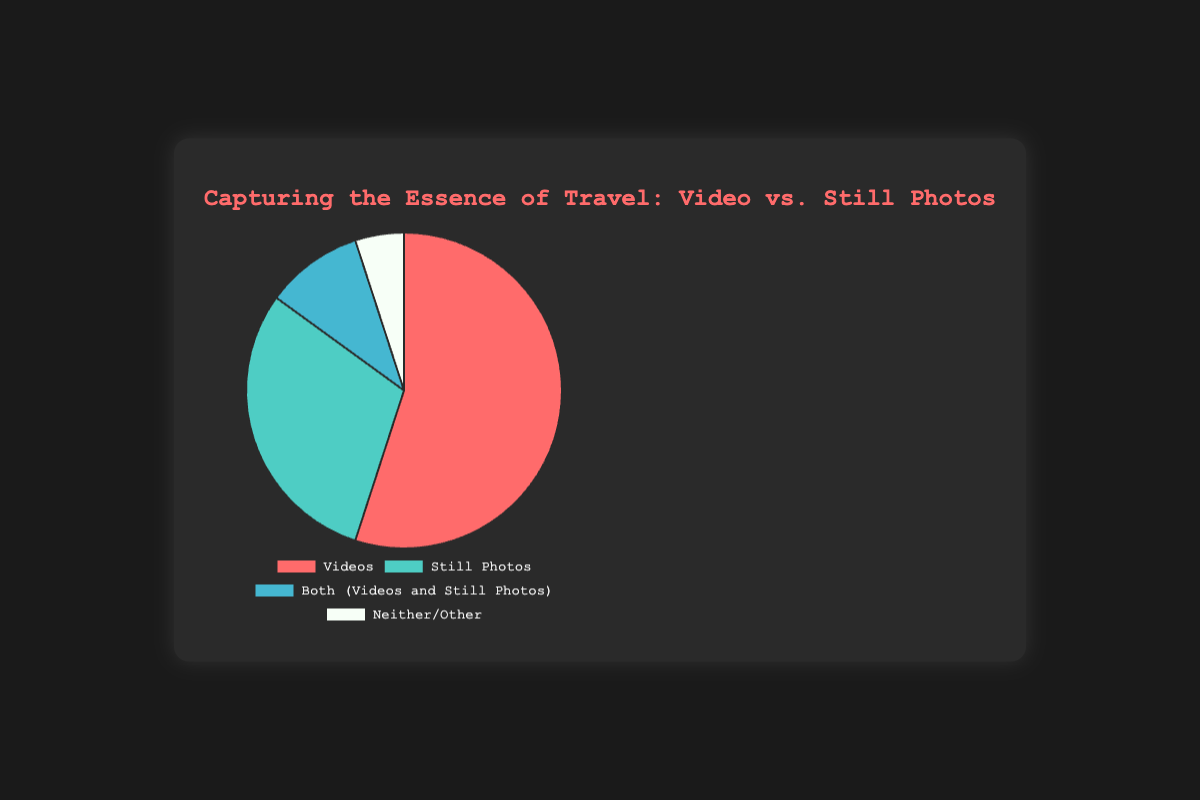What percentage of travelers prefer videos over still photos? The pie chart shows that 55% of travelers prefer videos, while 30% prefer still photos. Therefore, the percentage of travelers that prefer videos over still photos can be directly read from the chart.
Answer: 55% What is the combined percentage of travelers who prefer either videos or both (videos and still photos)? The pie chart displays 55% of travelers preferring videos and 10% preferring both. Adding these percentages gives 55% + 10%.
Answer: 65% Which category has the least preference among travelers? Analyzing the pie chart for the smallest segment reveals that "Neither/Other" has the least preference, accounting for only 5% of travelers.
Answer: Neither/Other, 5% By how much is the preference for videos greater than that for still photos? The chart shows 55% for videos and 30% for still photos. Subtraction will give the difference: 55% - 30%.
Answer: 25% What is the color representing the preference for both videos and still photos? The chart uses colors to differentiate between the categories. The segment for "Both (Videos and Still Photos)" is represented by a light blue color in the pie chart.
Answer: Light blue If 200 travelers were surveyed, how many of them prefer still photos? According to the chart, 30% of travelers prefer still photos. Calculating 30% of 200 (0.30 * 200) gives the number of travelers.
Answer: 60 What percentage of travelers do not prefer videos at all (still photos or neither)? Adding the percentages for "Still Photos" (30%) and "Neither/Other" (5%) gives us the combined percentage of travelers who do not prefer videos at all.
Answer: 35% Which category is more preferred: still photos or both (videos and still photos)? The pie chart indicates 30% preference for still photos and 10% for both. Still photos are more preferred.
Answer: Still photos What’s the percentage difference between the least and the most preferred options? The least preferred option ("Neither/Other") has 5%, while the most preferred ("Videos") has 55%. Subtracting these values gives the difference: 55% - 5%.
Answer: 50% What is the total percentage of travelers who prefer some form of visual media (either videos, still photos, or both)? Summing the percentages for "Videos" (55%), "Still Photos" (30%), and "Both" (10%) gives the total percentage: 55% + 30% + 10%.
Answer: 95% 